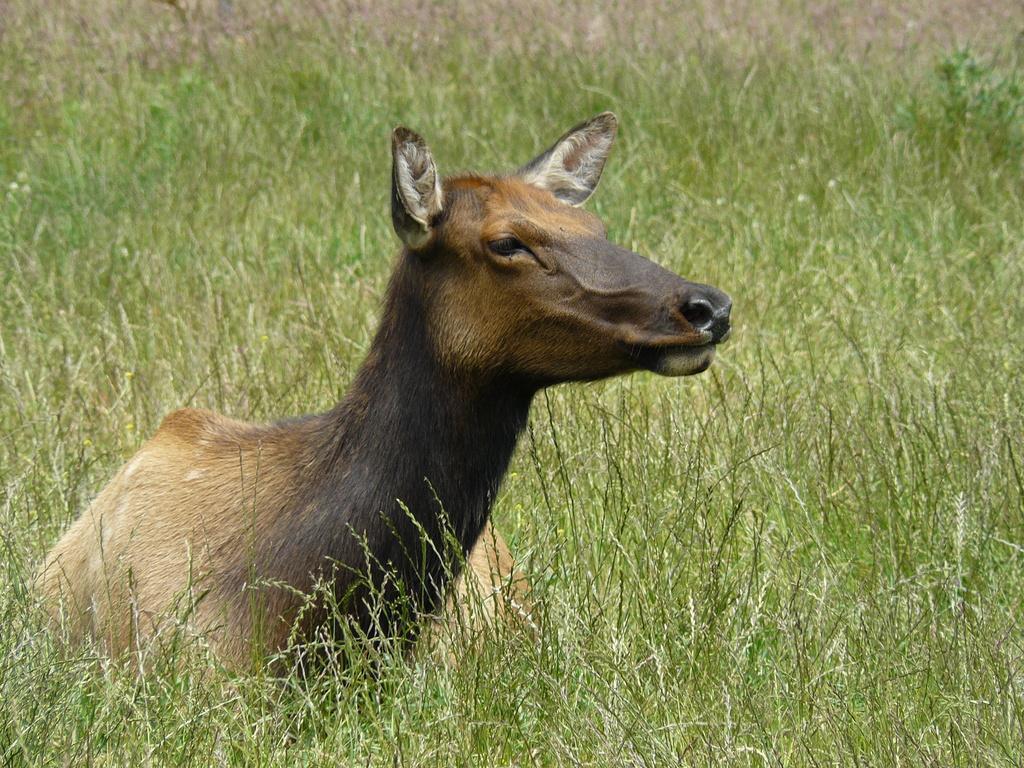In one or two sentences, can you explain what this image depicts? In the center of the image we can see animal laying on the plants. In the background we can see grass and plants. 